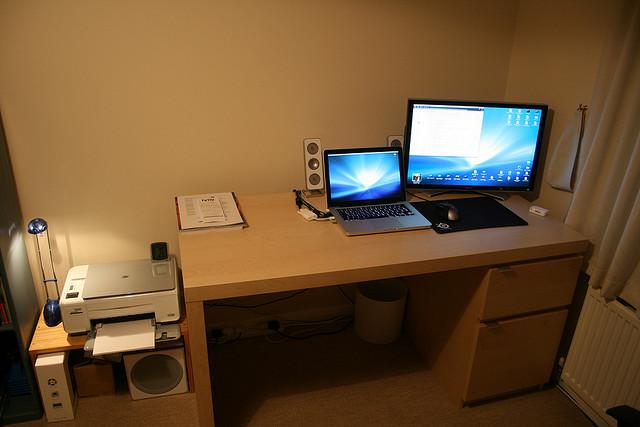Is there paper on the printer?
Short answer required. Yes. What room is this?
Quick response, please. Office. Is this called a workstation?
Answer briefly. Yes. 